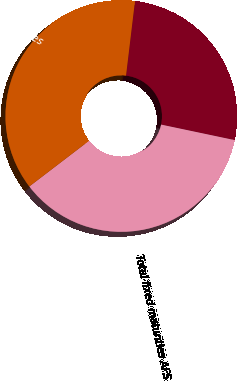Convert chart to OTSL. <chart><loc_0><loc_0><loc_500><loc_500><pie_chart><fcel>CMBS<fcel>Total fixed maturities AFS<fcel>Total AFS securities<nl><fcel>26.4%<fcel>36.3%<fcel>37.29%<nl></chart> 